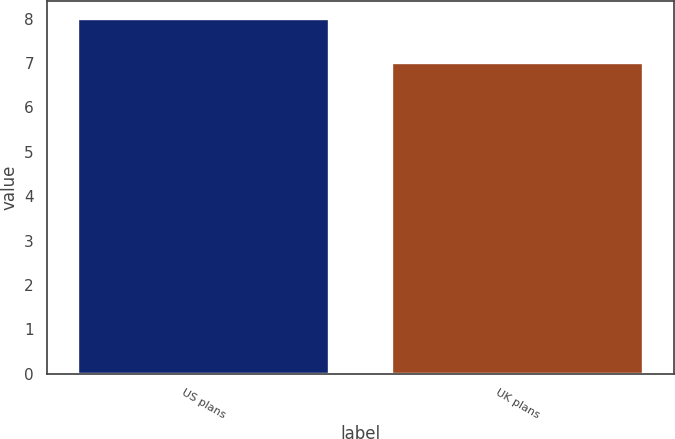Convert chart. <chart><loc_0><loc_0><loc_500><loc_500><bar_chart><fcel>US plans<fcel>UK plans<nl><fcel>8<fcel>7<nl></chart> 